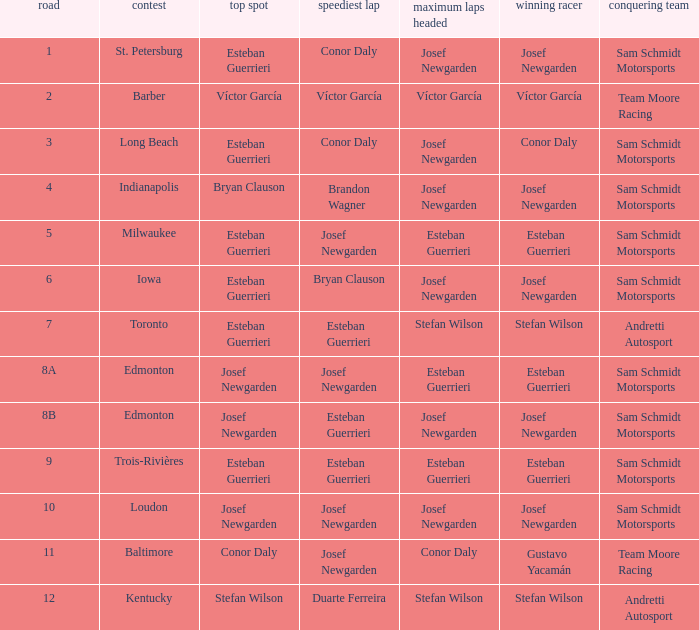Who had the fastest lap(s) when josef newgarden led the most laps at edmonton? Esteban Guerrieri. 